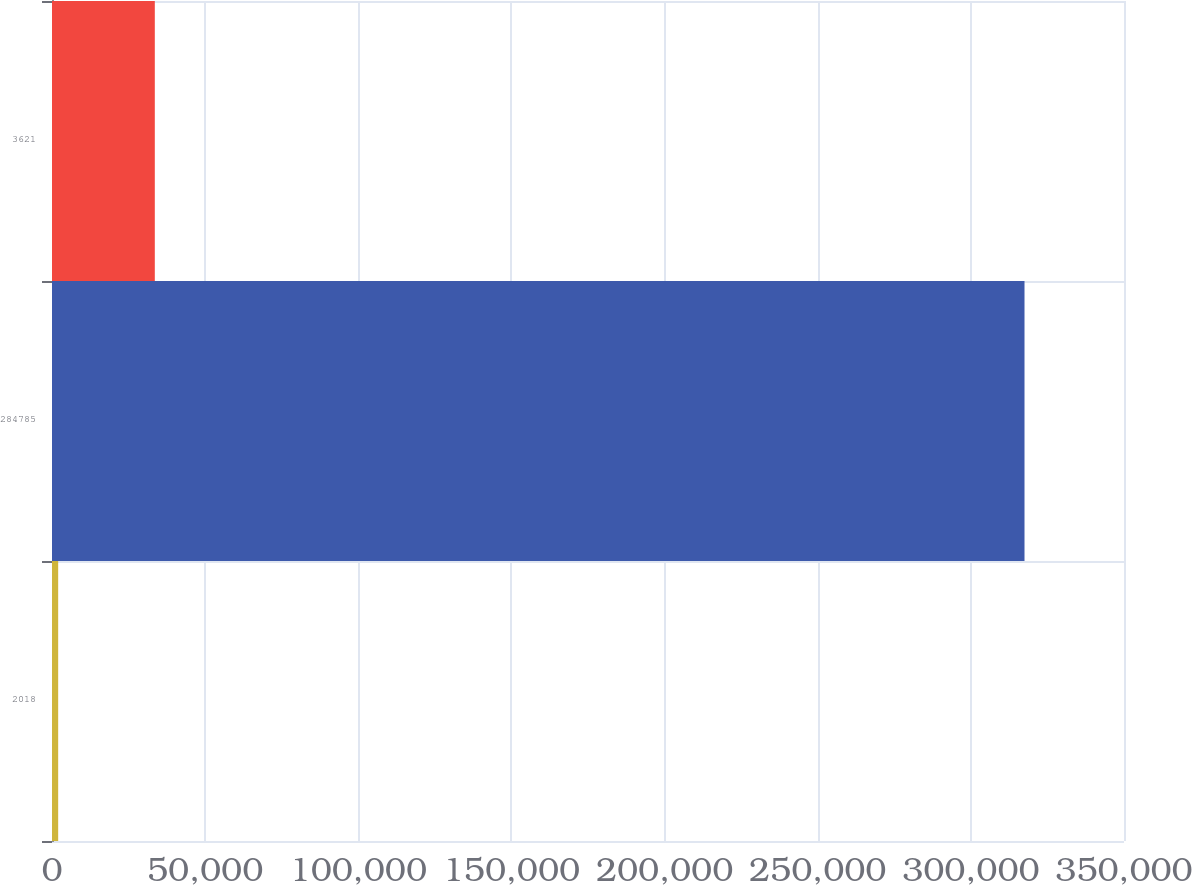Convert chart. <chart><loc_0><loc_0><loc_500><loc_500><bar_chart><fcel>2018<fcel>284785<fcel>3621<nl><fcel>2017<fcel>317515<fcel>33566.8<nl></chart> 